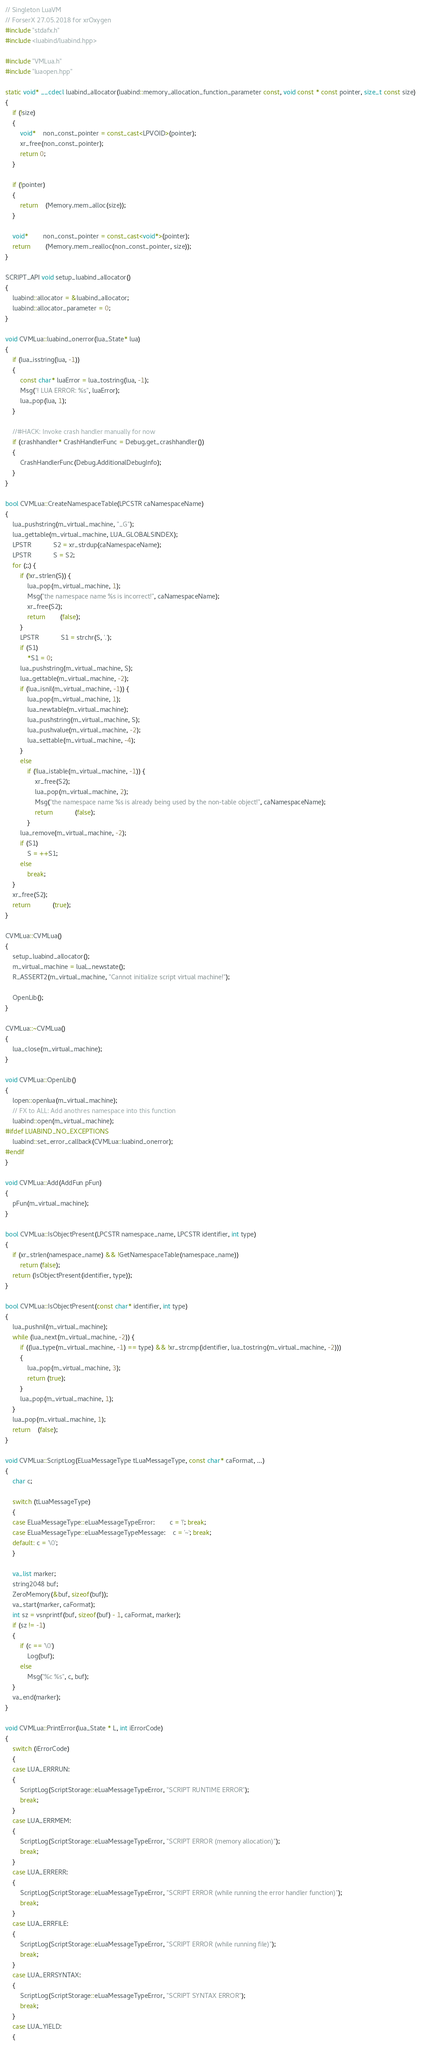Convert code to text. <code><loc_0><loc_0><loc_500><loc_500><_C++_>// Singleton LuaVM 
// ForserX 27.05.2018 for xrOxygen
#include "stdafx.h"
#include <luabind/luabind.hpp>

#include "VMLua.h"
#include "luaopen.hpp"

static void* __cdecl luabind_allocator(luabind::memory_allocation_function_parameter const, void const * const pointer, size_t const size)
{
	if (!size)
	{
		void*	non_const_pointer = const_cast<LPVOID>(pointer);
		xr_free(non_const_pointer);
		return 0;
	}

	if (!pointer)
	{
		return	(Memory.mem_alloc(size));
	}

	void*		non_const_pointer = const_cast<void*>(pointer);
	return		(Memory.mem_realloc(non_const_pointer, size));
}

SCRIPT_API void setup_luabind_allocator()
{
    luabind::allocator = &luabind_allocator;
    luabind::allocator_parameter = 0;
}

void CVMLua::luabind_onerror(lua_State* lua)
{
    if (lua_isstring(lua, -1))
    {
        const char* luaError = lua_tostring(lua, -1);
        Msg("! LUA ERROR: %s", luaError);
        lua_pop(lua, 1);
    }

    //#HACK: Invoke crash handler manually for now
    if (crashhandler* CrashHandlerFunc = Debug.get_crashhandler())
    {
        CrashHandlerFunc(Debug.AdditionalDebugInfo);
    }
}

bool CVMLua::CreateNamespaceTable(LPCSTR caNamespaceName)
{
	lua_pushstring(m_virtual_machine, "_G");
	lua_gettable(m_virtual_machine, LUA_GLOBALSINDEX);
	LPSTR			S2 = xr_strdup(caNamespaceName);
	LPSTR			S = S2;
	for (;;) {
		if (!xr_strlen(S)) {
			lua_pop(m_virtual_machine, 1);
			Msg("the namespace name %s is incorrect!", caNamespaceName);
			xr_free(S2);
			return		(false);
		}
		LPSTR			S1 = strchr(S, '.');
		if (S1)
			*S1 = 0;
		lua_pushstring(m_virtual_machine, S);
		lua_gettable(m_virtual_machine, -2);
		if (lua_isnil(m_virtual_machine, -1)) {
			lua_pop(m_virtual_machine, 1);
			lua_newtable(m_virtual_machine);
			lua_pushstring(m_virtual_machine, S);
			lua_pushvalue(m_virtual_machine, -2);
			lua_settable(m_virtual_machine, -4);
		}
		else
			if (!lua_istable(m_virtual_machine, -1)) {
				xr_free(S2);
				lua_pop(m_virtual_machine, 2);
				Msg("the namespace name %s is already being used by the non-table object!", caNamespaceName);
				return			(false);
			}
		lua_remove(m_virtual_machine, -2);
		if (S1)
			S = ++S1;
		else
			break;
	}
	xr_free(S2);
	return			(true);
}

CVMLua::CVMLua()
{
	setup_luabind_allocator();
	m_virtual_machine = luaL_newstate();
	R_ASSERT2(m_virtual_machine, "Cannot initialize script virtual machine!");

	OpenLib();
}

CVMLua::~CVMLua()
{
	lua_close(m_virtual_machine);
}

void CVMLua::OpenLib()
{
	lopen::openlua(m_virtual_machine);
	// FX to ALL: Add anothres namespace into this function
	luabind::open(m_virtual_machine);
#ifdef LUABIND_NO_EXCEPTIONS
    luabind::set_error_callback(CVMLua::luabind_onerror);
#endif
}

void CVMLua::Add(AddFun pFun)
{
	pFun(m_virtual_machine);
}

bool CVMLua::IsObjectPresent(LPCSTR namespace_name, LPCSTR identifier, int type)
{
	if (xr_strlen(namespace_name) && !GetNamespaceTable(namespace_name))
		return (false);
	return (IsObjectPresent(identifier, type));
}

bool CVMLua::IsObjectPresent(const char* identifier, int type)
{
	lua_pushnil(m_virtual_machine);
	while (lua_next(m_virtual_machine, -2)) {
		if ((lua_type(m_virtual_machine, -1) == type) && !xr_strcmp(identifier, lua_tostring(m_virtual_machine, -2))) 
		{
			lua_pop(m_virtual_machine, 3);
			return (true);
		}
		lua_pop(m_virtual_machine, 1);
	}
	lua_pop(m_virtual_machine, 1);
	return	(false);
}

void CVMLua::ScriptLog(ELuaMessageType tLuaMessageType, const char* caFormat, ...)
{
	char c;

	switch (tLuaMessageType)
	{
	case ELuaMessageType::eLuaMessageTypeError:		c = '!'; break;
	case ELuaMessageType::eLuaMessageTypeMessage:	c = '~'; break;
	default: c = '\0';
	}

	va_list marker;
	string2048 buf;
	ZeroMemory(&buf, sizeof(buf));
	va_start(marker, caFormat);
	int sz = vsnprintf(buf, sizeof(buf) - 1, caFormat, marker);
	if (sz != -1)
	{
		if (c == '\0')
			Log(buf);
		else
			Msg("%c %s", c, buf);
	}
	va_end(marker);
}

void CVMLua::PrintError(lua_State * L, int iErrorCode)
{
	switch (iErrorCode)
	{
	case LUA_ERRRUN:
	{
		ScriptLog(ScriptStorage::eLuaMessageTypeError, "SCRIPT RUNTIME ERROR");
		break;
	}
	case LUA_ERRMEM:
	{
		ScriptLog(ScriptStorage::eLuaMessageTypeError, "SCRIPT ERROR (memory allocation)");
		break;
	}
	case LUA_ERRERR: 
	{
		ScriptLog(ScriptStorage::eLuaMessageTypeError, "SCRIPT ERROR (while running the error handler function)");
		break;
	}
	case LUA_ERRFILE: 
	{
		ScriptLog(ScriptStorage::eLuaMessageTypeError, "SCRIPT ERROR (while running file)");
		break;
	}
	case LUA_ERRSYNTAX: 
	{
		ScriptLog(ScriptStorage::eLuaMessageTypeError, "SCRIPT SYNTAX ERROR");
		break;
	}
	case LUA_YIELD:
	{</code> 